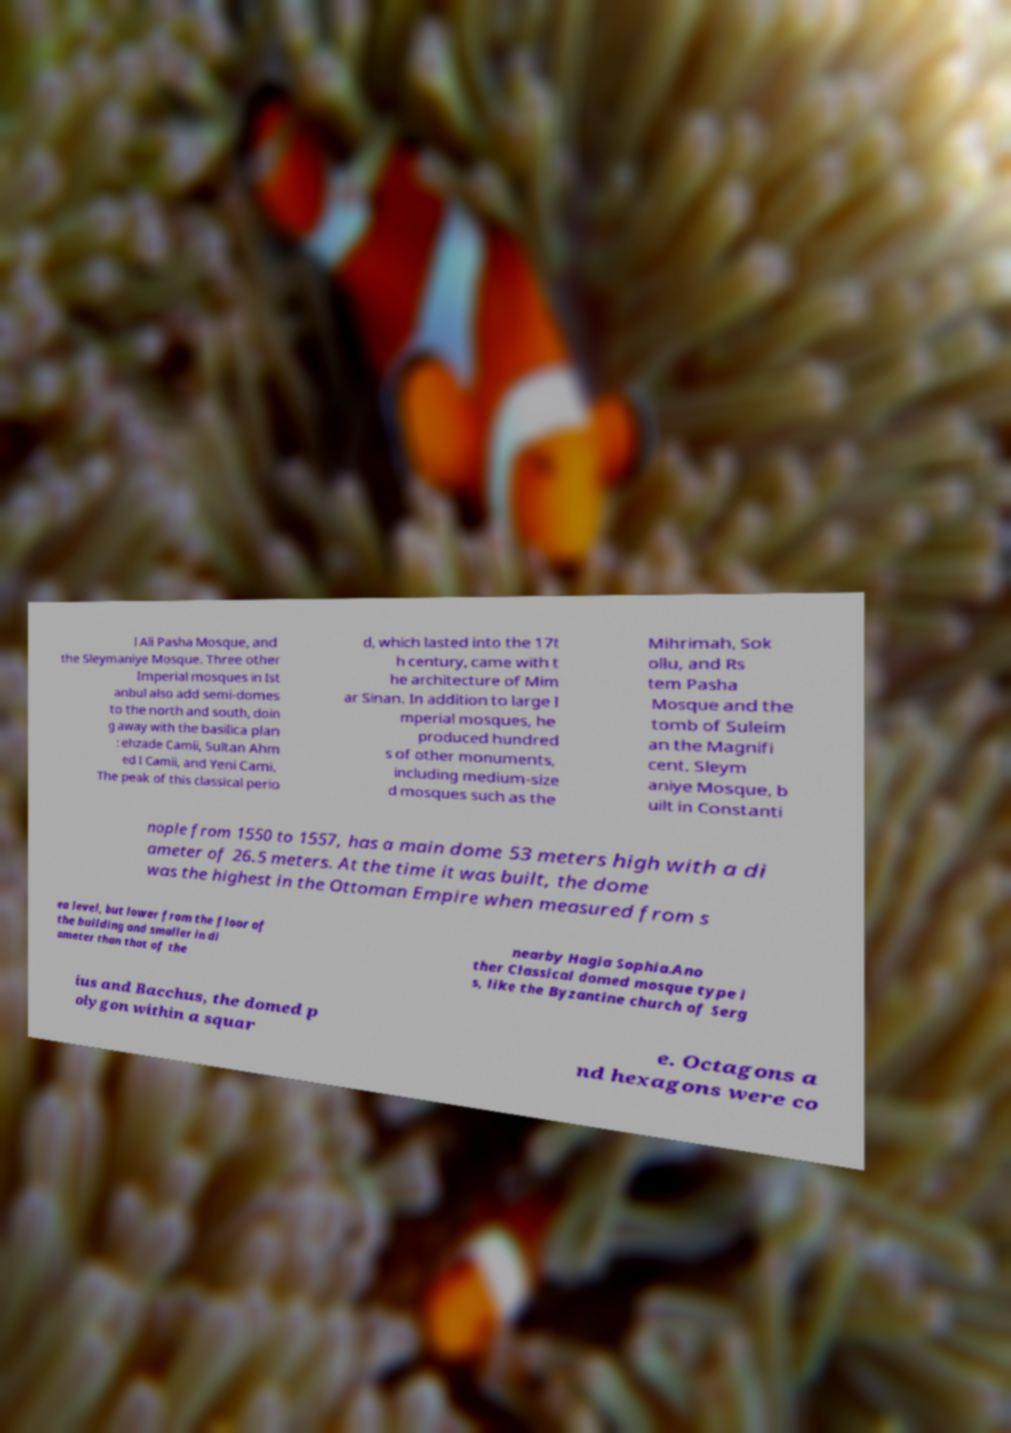Please read and relay the text visible in this image. What does it say? l Ali Pasha Mosque, and the Sleymaniye Mosque. Three other Imperial mosques in Ist anbul also add semi-domes to the north and south, doin g away with the basilica plan : ehzade Camii, Sultan Ahm ed I Camii, and Yeni Cami. The peak of this classical perio d, which lasted into the 17t h century, came with t he architecture of Mim ar Sinan. In addition to large I mperial mosques, he produced hundred s of other monuments, including medium-size d mosques such as the Mihrimah, Sok ollu, and Rs tem Pasha Mosque and the tomb of Suleim an the Magnifi cent. Sleym aniye Mosque, b uilt in Constanti nople from 1550 to 1557, has a main dome 53 meters high with a di ameter of 26.5 meters. At the time it was built, the dome was the highest in the Ottoman Empire when measured from s ea level, but lower from the floor of the building and smaller in di ameter than that of the nearby Hagia Sophia.Ano ther Classical domed mosque type i s, like the Byzantine church of Serg ius and Bacchus, the domed p olygon within a squar e. Octagons a nd hexagons were co 